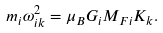<formula> <loc_0><loc_0><loc_500><loc_500>m _ { i } \omega _ { i k } ^ { 2 } = \mu _ { B } G _ { i } M _ { F i } K _ { k } .</formula> 